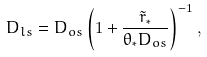<formula> <loc_0><loc_0><loc_500><loc_500>D _ { l s } = D _ { o s } \left ( 1 + \frac { \tilde { r } _ { * } } { \theta _ { * } D _ { o s } } \right ) ^ { - 1 } ,</formula> 